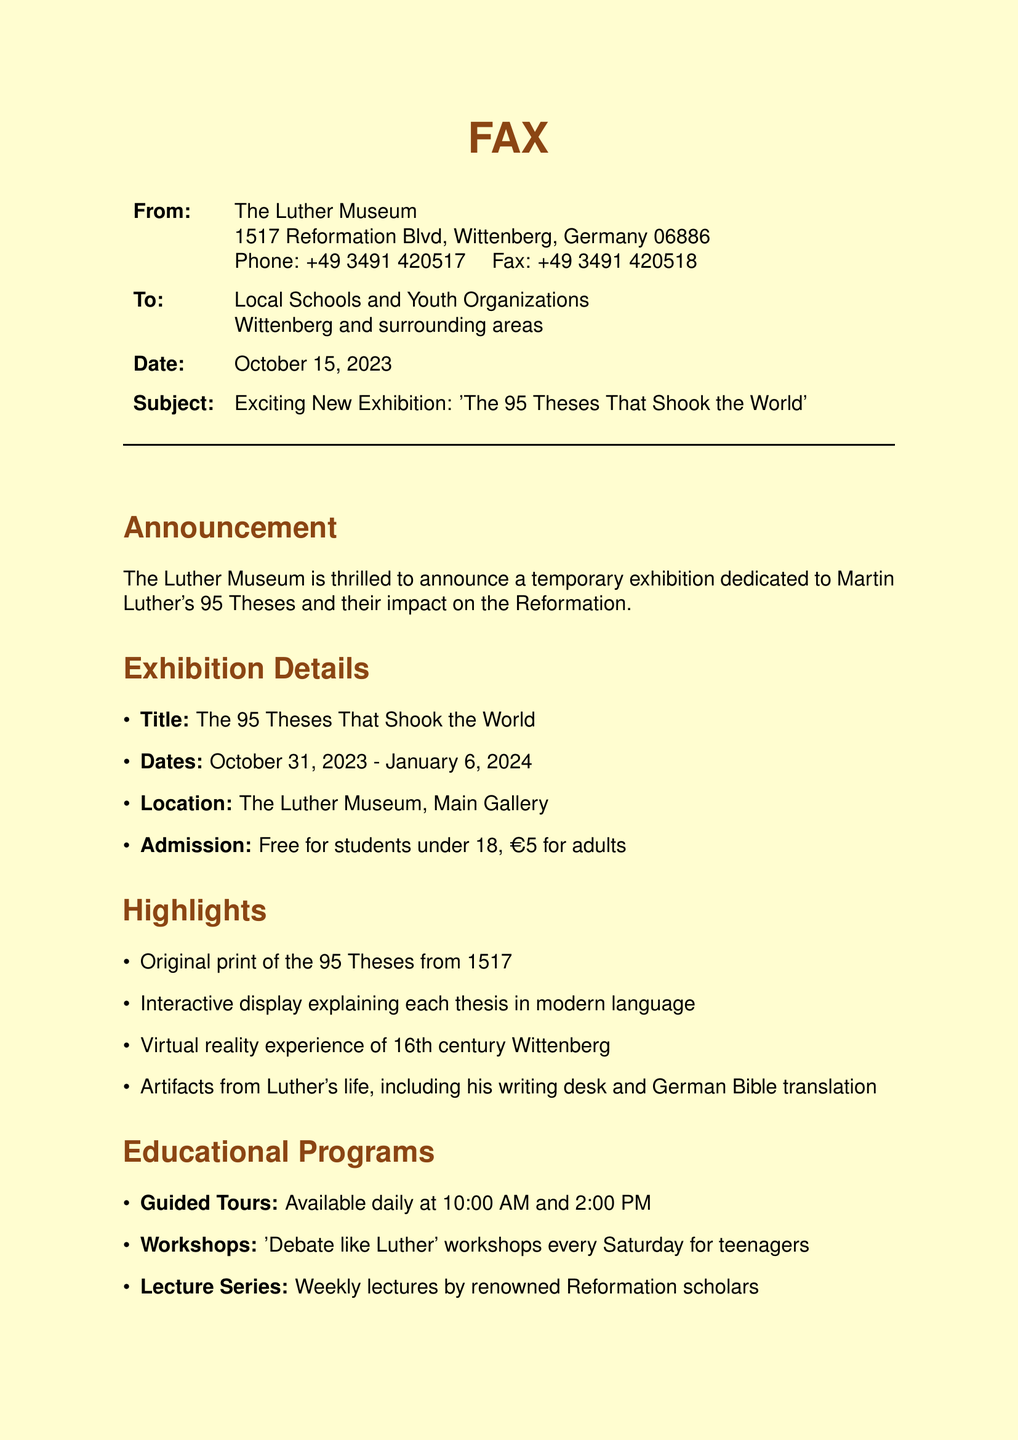What is the subject of the fax? The subject clearly states the focus of the announcement, which is the temporary exhibition at the museum.
Answer: Exciting New Exhibition: 'The 95 Theses That Shook the World' What are the admission fees for adults? The document specifies the cost for adults attending the exhibition.
Answer: €5 for adults When does the exhibition start? The starting date for the exhibition is mentioned in the details section.
Answer: October 31, 2023 What special offer is mentioned for teenage visitors? There is a specific offer highlighted for young visitors to entice their attendance.
Answer: Free 'Reformer in Training' t-shirt What type of workshop is available for teenagers? The document includes specific educational programs available at the exhibition, including workshops for a targeted audience.
Answer: 'Debate like Luther' Where is the exhibition located? The location of the exhibition is provided in the document under the exhibition details section.
Answer: The Luther Museum, Main Gallery How long will the exhibition last? The duration for which the exhibition will be open to the public is outlined in the document.
Answer: January 6, 2024 What is the phone number of the Luther Museum? The contact information is presented in the fax, including the museum's phone number for inquiries.
Answer: +49 3491 420517 